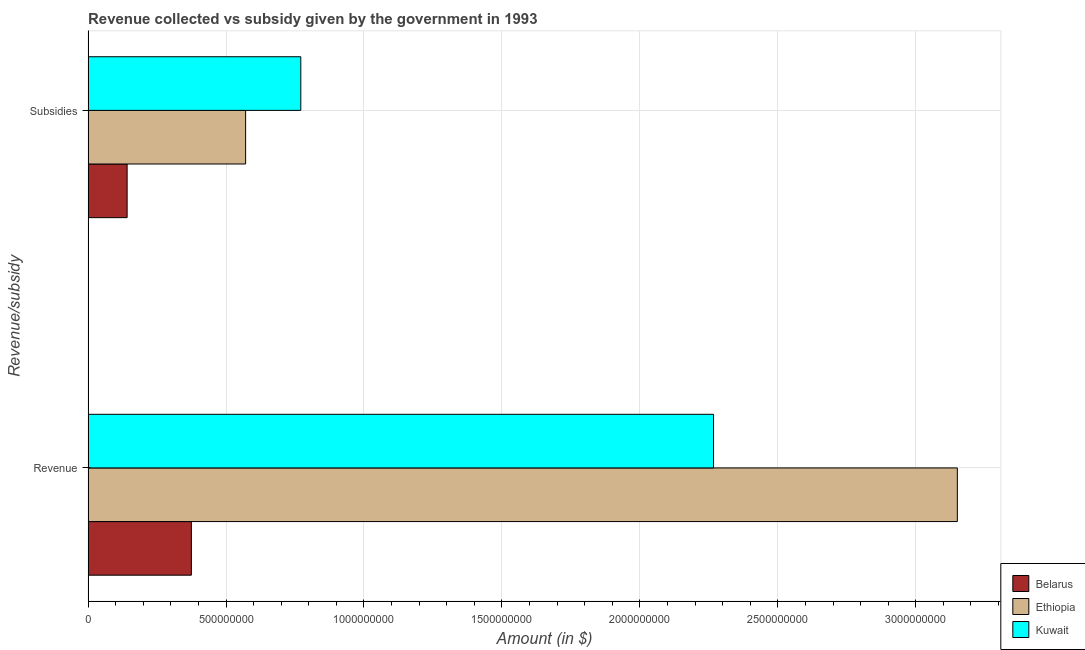How many groups of bars are there?
Make the answer very short. 2. Are the number of bars on each tick of the Y-axis equal?
Offer a terse response. Yes. How many bars are there on the 2nd tick from the top?
Offer a very short reply. 3. How many bars are there on the 2nd tick from the bottom?
Keep it short and to the point. 3. What is the label of the 1st group of bars from the top?
Ensure brevity in your answer.  Subsidies. What is the amount of revenue collected in Ethiopia?
Make the answer very short. 3.15e+09. Across all countries, what is the maximum amount of revenue collected?
Offer a very short reply. 3.15e+09. Across all countries, what is the minimum amount of subsidies given?
Provide a short and direct response. 1.42e+08. In which country was the amount of subsidies given maximum?
Your answer should be compact. Kuwait. In which country was the amount of revenue collected minimum?
Make the answer very short. Belarus. What is the total amount of subsidies given in the graph?
Your response must be concise. 1.48e+09. What is the difference between the amount of subsidies given in Belarus and that in Kuwait?
Provide a short and direct response. -6.30e+08. What is the difference between the amount of revenue collected in Ethiopia and the amount of subsidies given in Kuwait?
Ensure brevity in your answer.  2.38e+09. What is the average amount of subsidies given per country?
Keep it short and to the point. 4.94e+08. What is the difference between the amount of revenue collected and amount of subsidies given in Ethiopia?
Your response must be concise. 2.58e+09. In how many countries, is the amount of subsidies given greater than 3000000000 $?
Your answer should be very brief. 0. What is the ratio of the amount of subsidies given in Belarus to that in Kuwait?
Keep it short and to the point. 0.18. Is the amount of subsidies given in Kuwait less than that in Belarus?
Your answer should be very brief. No. What does the 2nd bar from the top in Subsidies represents?
Give a very brief answer. Ethiopia. What does the 1st bar from the bottom in Revenue represents?
Your answer should be very brief. Belarus. How many bars are there?
Make the answer very short. 6. Are all the bars in the graph horizontal?
Ensure brevity in your answer.  Yes. How many countries are there in the graph?
Provide a short and direct response. 3. What is the difference between two consecutive major ticks on the X-axis?
Give a very brief answer. 5.00e+08. Are the values on the major ticks of X-axis written in scientific E-notation?
Provide a short and direct response. No. Does the graph contain any zero values?
Ensure brevity in your answer.  No. How many legend labels are there?
Your answer should be compact. 3. How are the legend labels stacked?
Provide a short and direct response. Vertical. What is the title of the graph?
Offer a terse response. Revenue collected vs subsidy given by the government in 1993. What is the label or title of the X-axis?
Offer a very short reply. Amount (in $). What is the label or title of the Y-axis?
Provide a succinct answer. Revenue/subsidy. What is the Amount (in $) of Belarus in Revenue?
Make the answer very short. 3.74e+08. What is the Amount (in $) of Ethiopia in Revenue?
Make the answer very short. 3.15e+09. What is the Amount (in $) of Kuwait in Revenue?
Offer a terse response. 2.27e+09. What is the Amount (in $) in Belarus in Subsidies?
Provide a short and direct response. 1.42e+08. What is the Amount (in $) of Ethiopia in Subsidies?
Provide a succinct answer. 5.71e+08. What is the Amount (in $) in Kuwait in Subsidies?
Your response must be concise. 7.71e+08. Across all Revenue/subsidy, what is the maximum Amount (in $) in Belarus?
Provide a short and direct response. 3.74e+08. Across all Revenue/subsidy, what is the maximum Amount (in $) of Ethiopia?
Your answer should be compact. 3.15e+09. Across all Revenue/subsidy, what is the maximum Amount (in $) in Kuwait?
Offer a very short reply. 2.27e+09. Across all Revenue/subsidy, what is the minimum Amount (in $) in Belarus?
Offer a terse response. 1.42e+08. Across all Revenue/subsidy, what is the minimum Amount (in $) in Ethiopia?
Make the answer very short. 5.71e+08. Across all Revenue/subsidy, what is the minimum Amount (in $) of Kuwait?
Offer a very short reply. 7.71e+08. What is the total Amount (in $) of Belarus in the graph?
Provide a short and direct response. 5.16e+08. What is the total Amount (in $) in Ethiopia in the graph?
Your response must be concise. 3.72e+09. What is the total Amount (in $) in Kuwait in the graph?
Keep it short and to the point. 3.04e+09. What is the difference between the Amount (in $) of Belarus in Revenue and that in Subsidies?
Provide a succinct answer. 2.33e+08. What is the difference between the Amount (in $) in Ethiopia in Revenue and that in Subsidies?
Offer a very short reply. 2.58e+09. What is the difference between the Amount (in $) of Kuwait in Revenue and that in Subsidies?
Ensure brevity in your answer.  1.50e+09. What is the difference between the Amount (in $) in Belarus in Revenue and the Amount (in $) in Ethiopia in Subsidies?
Your answer should be very brief. -1.97e+08. What is the difference between the Amount (in $) of Belarus in Revenue and the Amount (in $) of Kuwait in Subsidies?
Keep it short and to the point. -3.97e+08. What is the difference between the Amount (in $) of Ethiopia in Revenue and the Amount (in $) of Kuwait in Subsidies?
Your response must be concise. 2.38e+09. What is the average Amount (in $) in Belarus per Revenue/subsidy?
Your answer should be compact. 2.58e+08. What is the average Amount (in $) of Ethiopia per Revenue/subsidy?
Make the answer very short. 1.86e+09. What is the average Amount (in $) of Kuwait per Revenue/subsidy?
Offer a very short reply. 1.52e+09. What is the difference between the Amount (in $) in Belarus and Amount (in $) in Ethiopia in Revenue?
Keep it short and to the point. -2.78e+09. What is the difference between the Amount (in $) in Belarus and Amount (in $) in Kuwait in Revenue?
Ensure brevity in your answer.  -1.89e+09. What is the difference between the Amount (in $) in Ethiopia and Amount (in $) in Kuwait in Revenue?
Offer a terse response. 8.84e+08. What is the difference between the Amount (in $) of Belarus and Amount (in $) of Ethiopia in Subsidies?
Provide a succinct answer. -4.30e+08. What is the difference between the Amount (in $) of Belarus and Amount (in $) of Kuwait in Subsidies?
Provide a succinct answer. -6.30e+08. What is the difference between the Amount (in $) in Ethiopia and Amount (in $) in Kuwait in Subsidies?
Your response must be concise. -2.00e+08. What is the ratio of the Amount (in $) in Belarus in Revenue to that in Subsidies?
Keep it short and to the point. 2.65. What is the ratio of the Amount (in $) of Ethiopia in Revenue to that in Subsidies?
Your answer should be compact. 5.52. What is the ratio of the Amount (in $) of Kuwait in Revenue to that in Subsidies?
Keep it short and to the point. 2.94. What is the difference between the highest and the second highest Amount (in $) in Belarus?
Ensure brevity in your answer.  2.33e+08. What is the difference between the highest and the second highest Amount (in $) in Ethiopia?
Give a very brief answer. 2.58e+09. What is the difference between the highest and the second highest Amount (in $) of Kuwait?
Keep it short and to the point. 1.50e+09. What is the difference between the highest and the lowest Amount (in $) of Belarus?
Give a very brief answer. 2.33e+08. What is the difference between the highest and the lowest Amount (in $) of Ethiopia?
Provide a short and direct response. 2.58e+09. What is the difference between the highest and the lowest Amount (in $) in Kuwait?
Your response must be concise. 1.50e+09. 